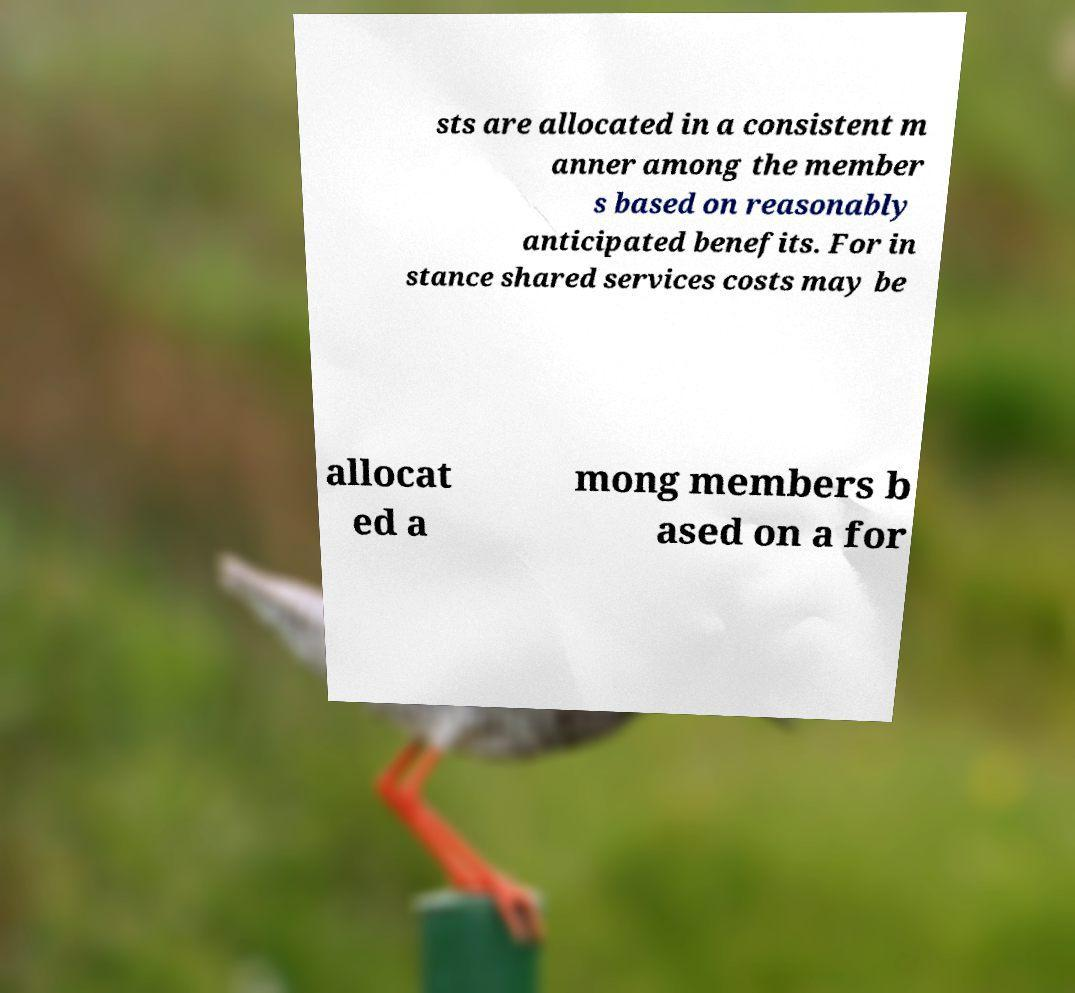Please identify and transcribe the text found in this image. sts are allocated in a consistent m anner among the member s based on reasonably anticipated benefits. For in stance shared services costs may be allocat ed a mong members b ased on a for 